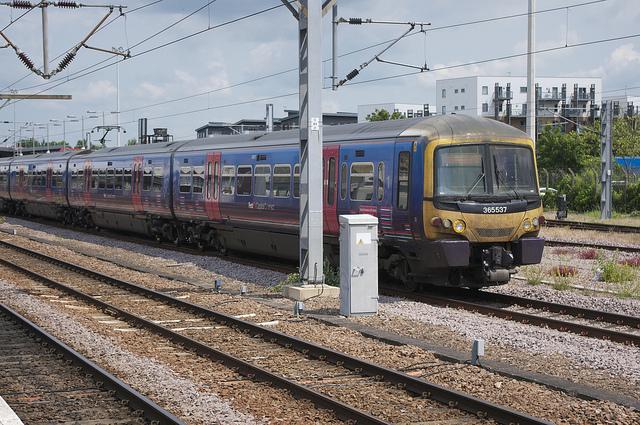Is there numbers on the front end of the train?
Quick response, please. Yes. Are the train tracks crowded?
Short answer required. No. Is this a train station?
Quick response, please. Yes. Is the sky clear?
Write a very short answer. No. 